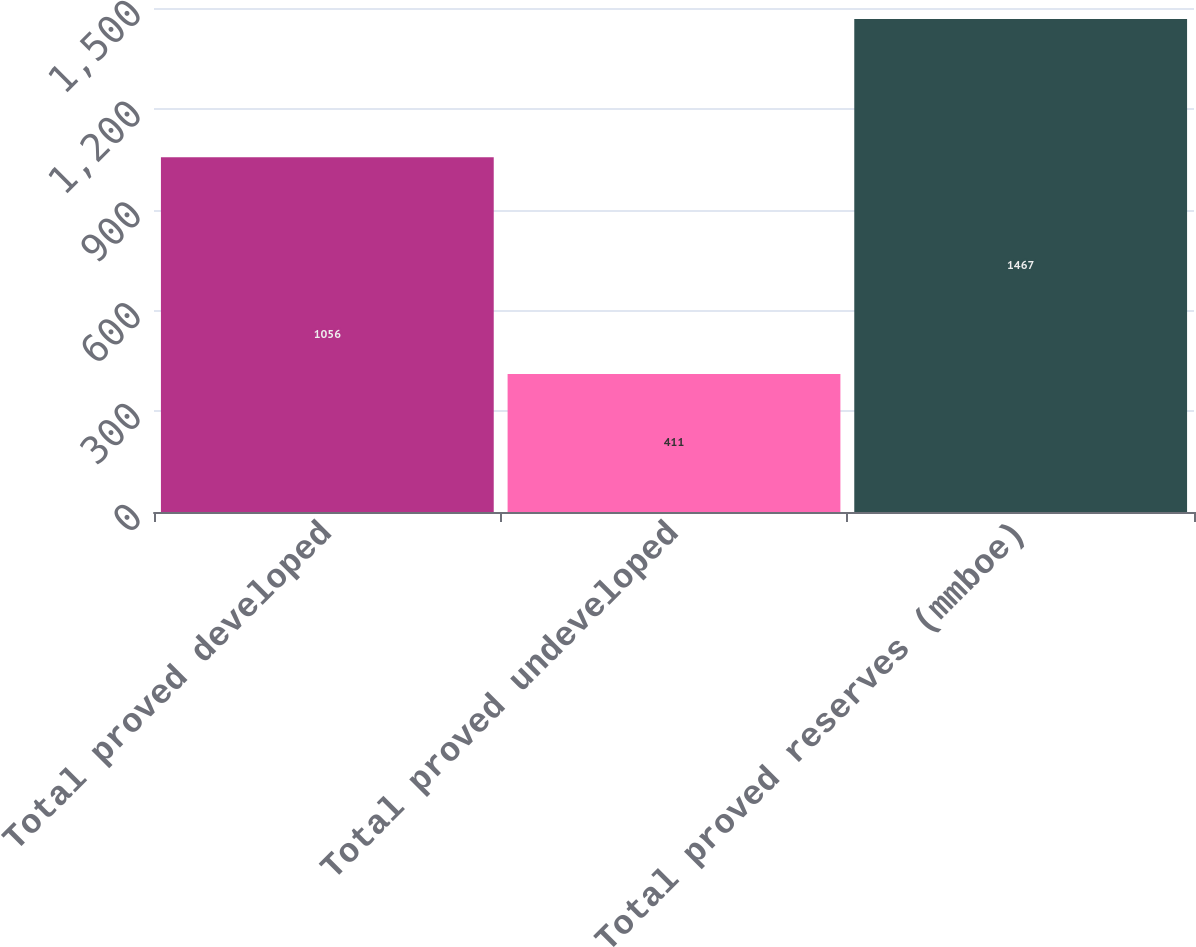<chart> <loc_0><loc_0><loc_500><loc_500><bar_chart><fcel>Total proved developed<fcel>Total proved undeveloped<fcel>Total proved reserves (mmboe)<nl><fcel>1056<fcel>411<fcel>1467<nl></chart> 